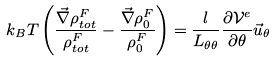<formula> <loc_0><loc_0><loc_500><loc_500>k _ { B } T \left ( \frac { \vec { \nabla } \rho _ { t o t } ^ { F } } { \rho _ { t o t } ^ { F } } - \frac { \vec { \nabla } \rho _ { 0 } ^ { F } } { \rho _ { 0 } ^ { F } } \right ) = \frac { l } { L _ { \theta \theta } } \frac { \partial \mathcal { V } ^ { e } } { \partial \theta } \vec { u } _ { \theta }</formula> 